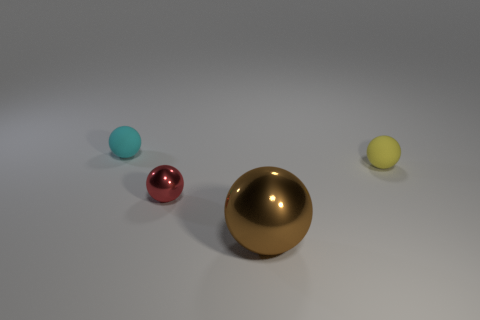Subtract all yellow matte spheres. How many spheres are left? 3 Subtract 2 balls. How many balls are left? 2 Add 4 tiny cyan spheres. How many objects exist? 8 Subtract all cyan spheres. How many spheres are left? 3 Subtract all red spheres. Subtract all green cylinders. How many spheres are left? 3 Subtract all tiny red things. Subtract all tiny cyan objects. How many objects are left? 2 Add 4 small red balls. How many small red balls are left? 5 Add 4 matte objects. How many matte objects exist? 6 Subtract 0 cyan cubes. How many objects are left? 4 